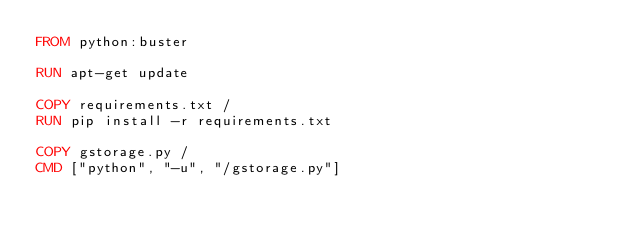Convert code to text. <code><loc_0><loc_0><loc_500><loc_500><_Dockerfile_>FROM python:buster

RUN apt-get update

COPY requirements.txt /
RUN pip install -r requirements.txt

COPY gstorage.py /
CMD ["python", "-u", "/gstorage.py"]
</code> 